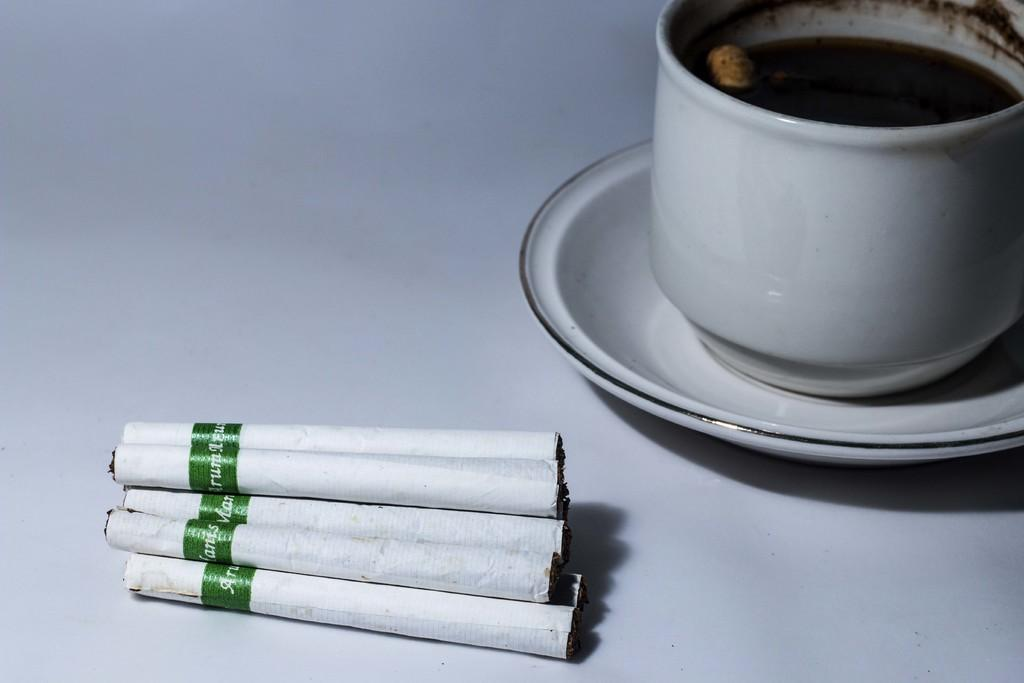What is placed on the saucer in the image? There is a cup of tea on a saucer in the image. What other items can be seen in the image? There are cigarettes in the image. What color is the stocking hanging from the lamp in the image? There is no stocking or lamp present in the image. What grade does the person in the image receive for their performance? There is no indication of a performance or grading system in the image. 